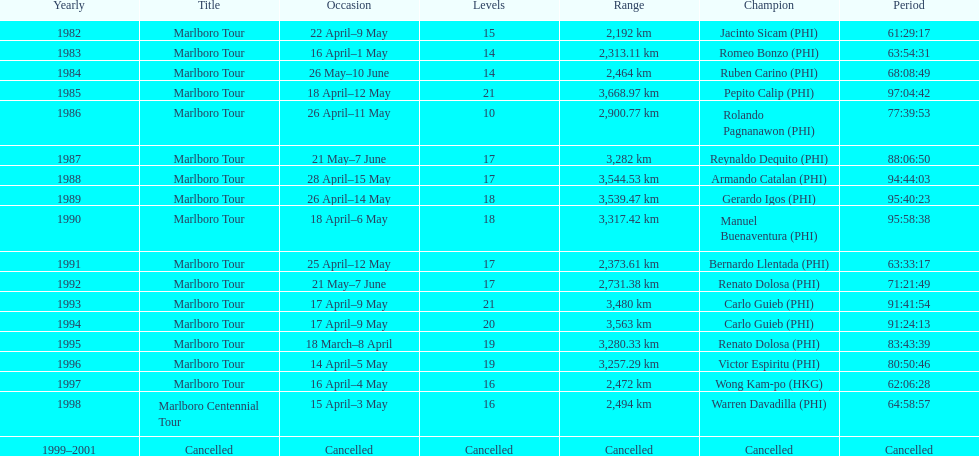How far did the marlboro tour travel each year? 2,192 km, 2,313.11 km, 2,464 km, 3,668.97 km, 2,900.77 km, 3,282 km, 3,544.53 km, 3,539.47 km, 3,317.42 km, 2,373.61 km, 2,731.38 km, 3,480 km, 3,563 km, 3,280.33 km, 3,257.29 km, 2,472 km, 2,494 km, Cancelled. In what year did they travel the furthest? 1985. How far did they travel that year? 3,668.97 km. 